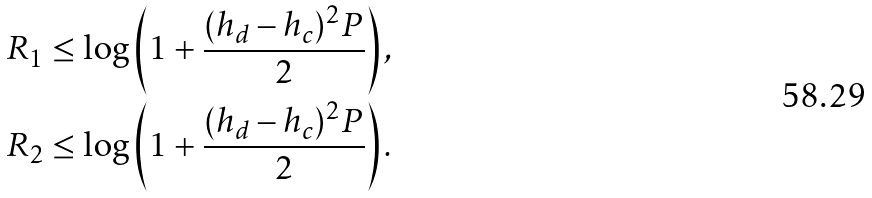Convert formula to latex. <formula><loc_0><loc_0><loc_500><loc_500>R _ { 1 } & \leq \log \left ( 1 + \frac { ( h _ { d } - h _ { c } ) ^ { 2 } P } { 2 } \right ) , \\ R _ { 2 } & \leq \log \left ( 1 + \frac { ( h _ { d } - h _ { c } ) ^ { 2 } P } { 2 } \right ) .</formula> 